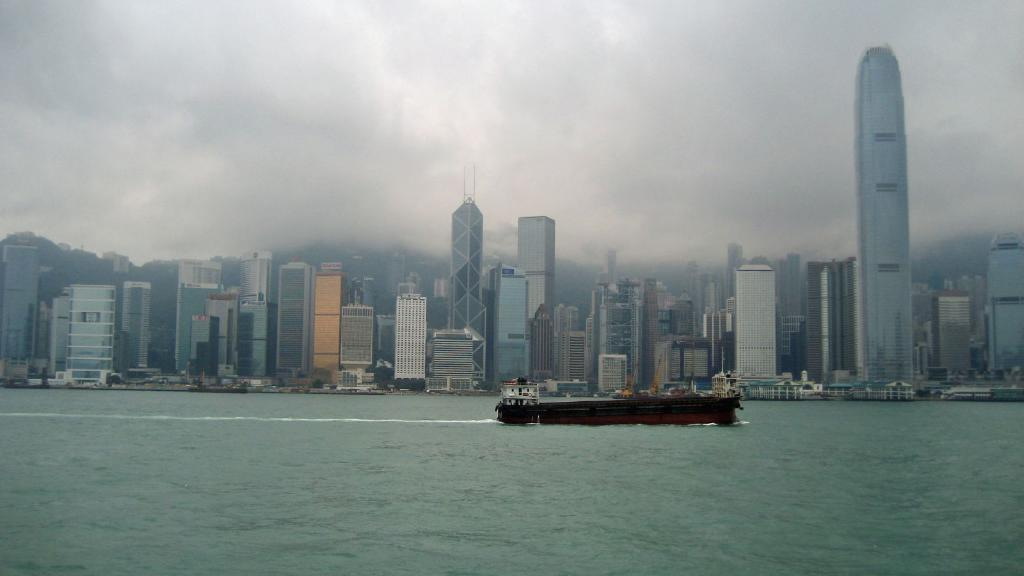What is the main subject of the image? The main subject of the image is a ship. Where is the ship located? The ship is on a river. What can be seen in the background of the image? There are huge buildings and the sky visible in the background of the image. What type of locket is hanging from the ship's mast in the image? There is no locket present on the ship's mast in the image. 